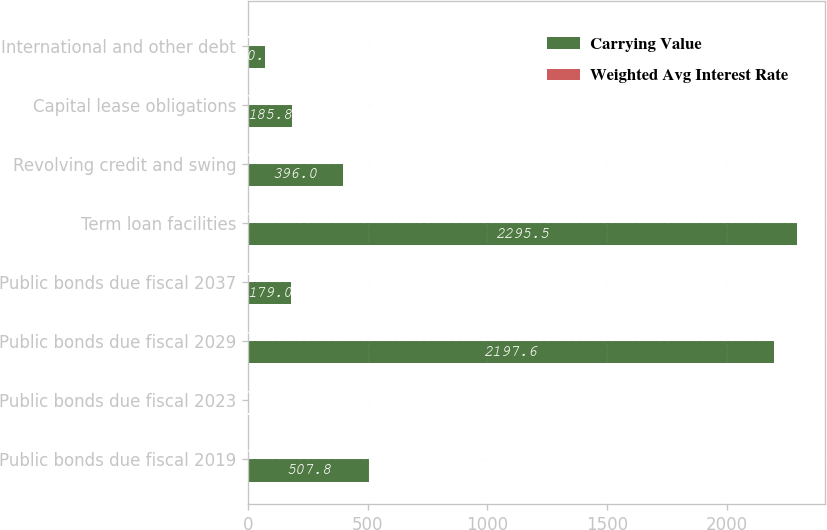<chart> <loc_0><loc_0><loc_500><loc_500><stacked_bar_chart><ecel><fcel>Public bonds due fiscal 2019<fcel>Public bonds due fiscal 2023<fcel>Public bonds due fiscal 2029<fcel>Public bonds due fiscal 2037<fcel>Term loan facilities<fcel>Revolving credit and swing<fcel>Capital lease obligations<fcel>International and other debt<nl><fcel>Carrying Value<fcel>507.8<fcel>6.6<fcel>2197.6<fcel>179<fcel>2295.5<fcel>396<fcel>185.8<fcel>70.2<nl><fcel>Weighted Avg Interest Rate<fcel>4.9<fcel>4<fcel>4.9<fcel>6.2<fcel>3.3<fcel>2.9<fcel>4.3<fcel>6.6<nl></chart> 